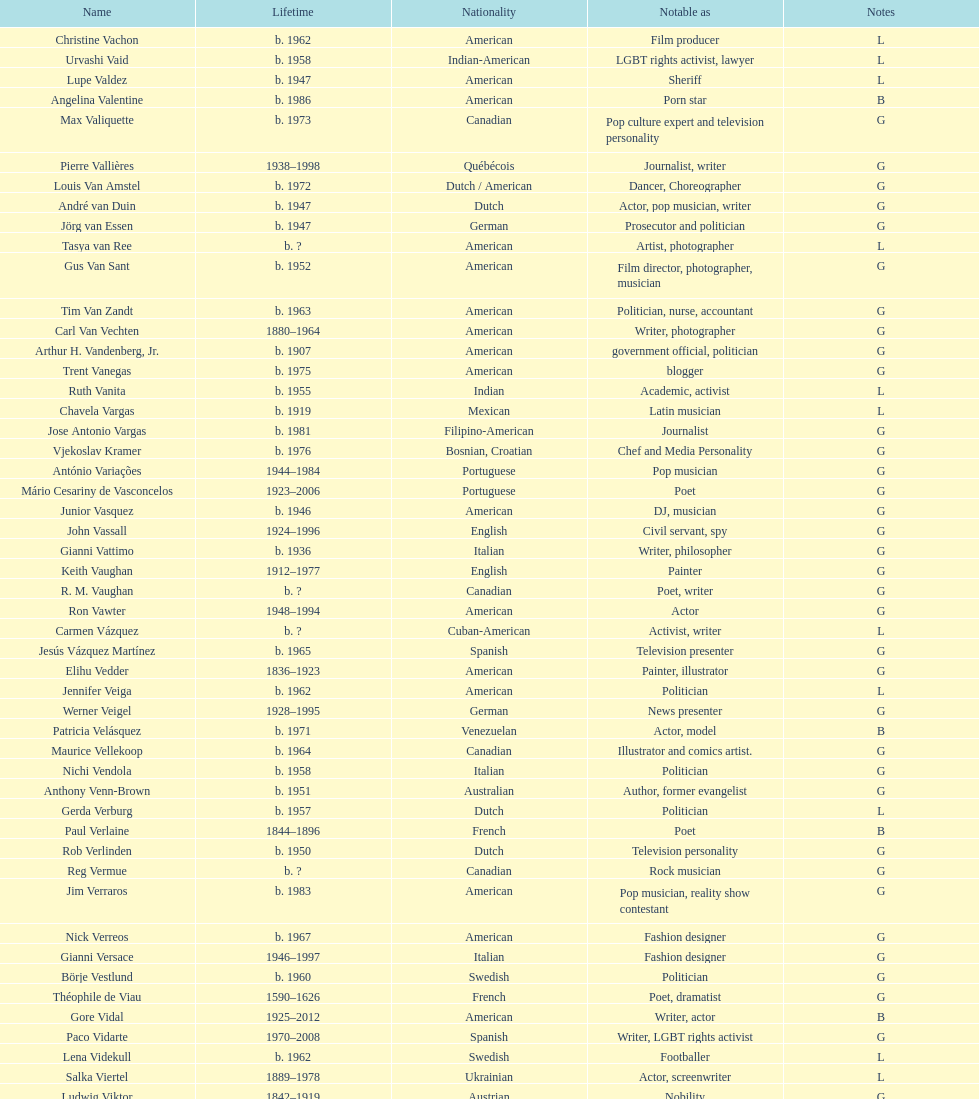Which nationality is linked to the highest number of individuals? American. 